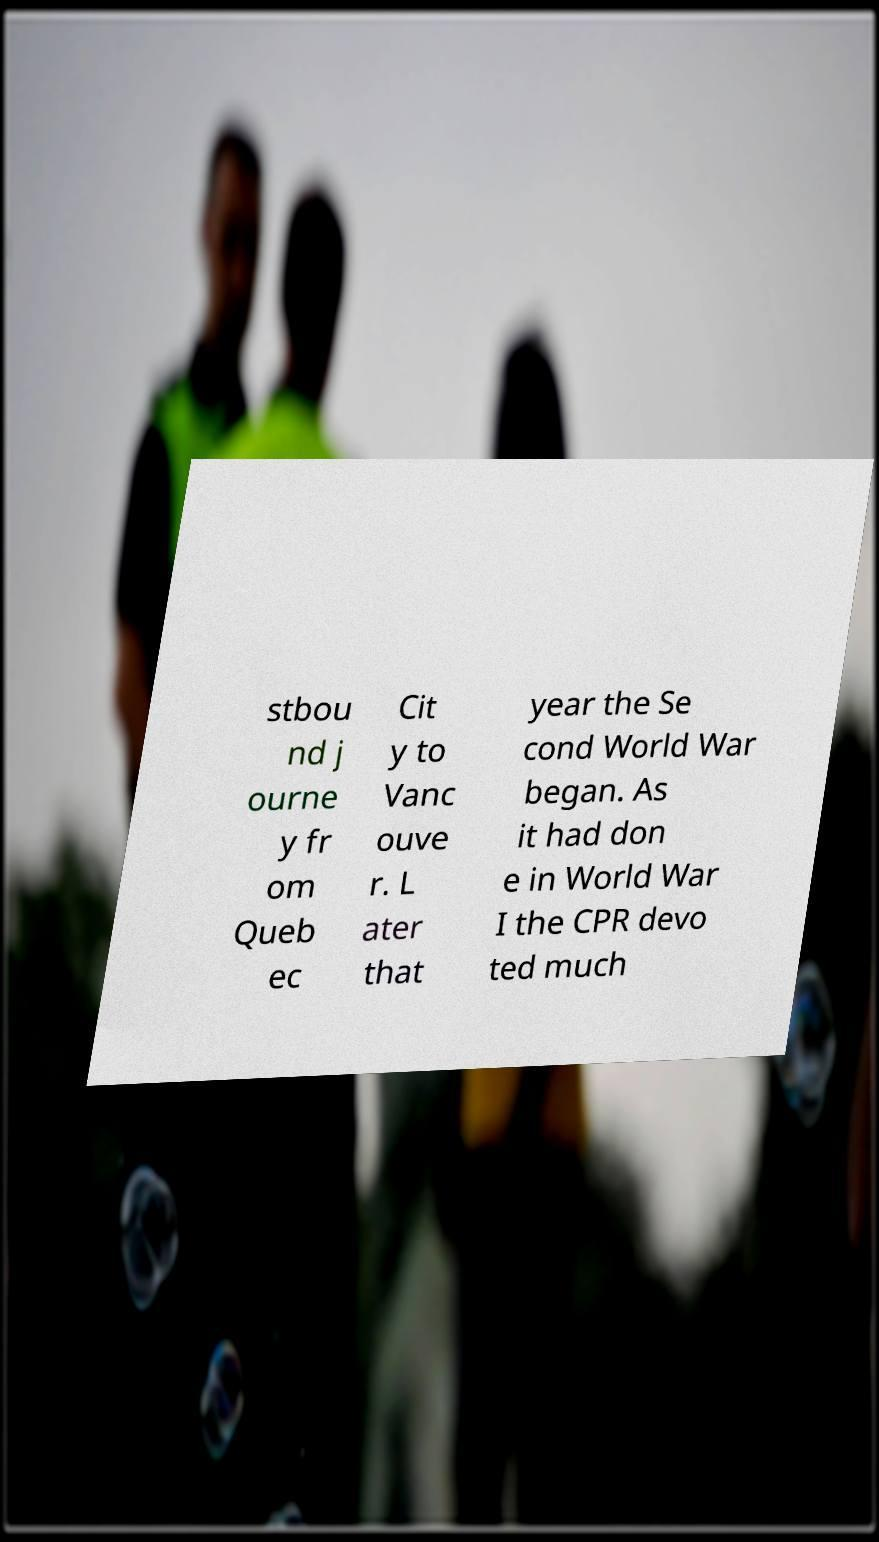Please read and relay the text visible in this image. What does it say? stbou nd j ourne y fr om Queb ec Cit y to Vanc ouve r. L ater that year the Se cond World War began. As it had don e in World War I the CPR devo ted much 